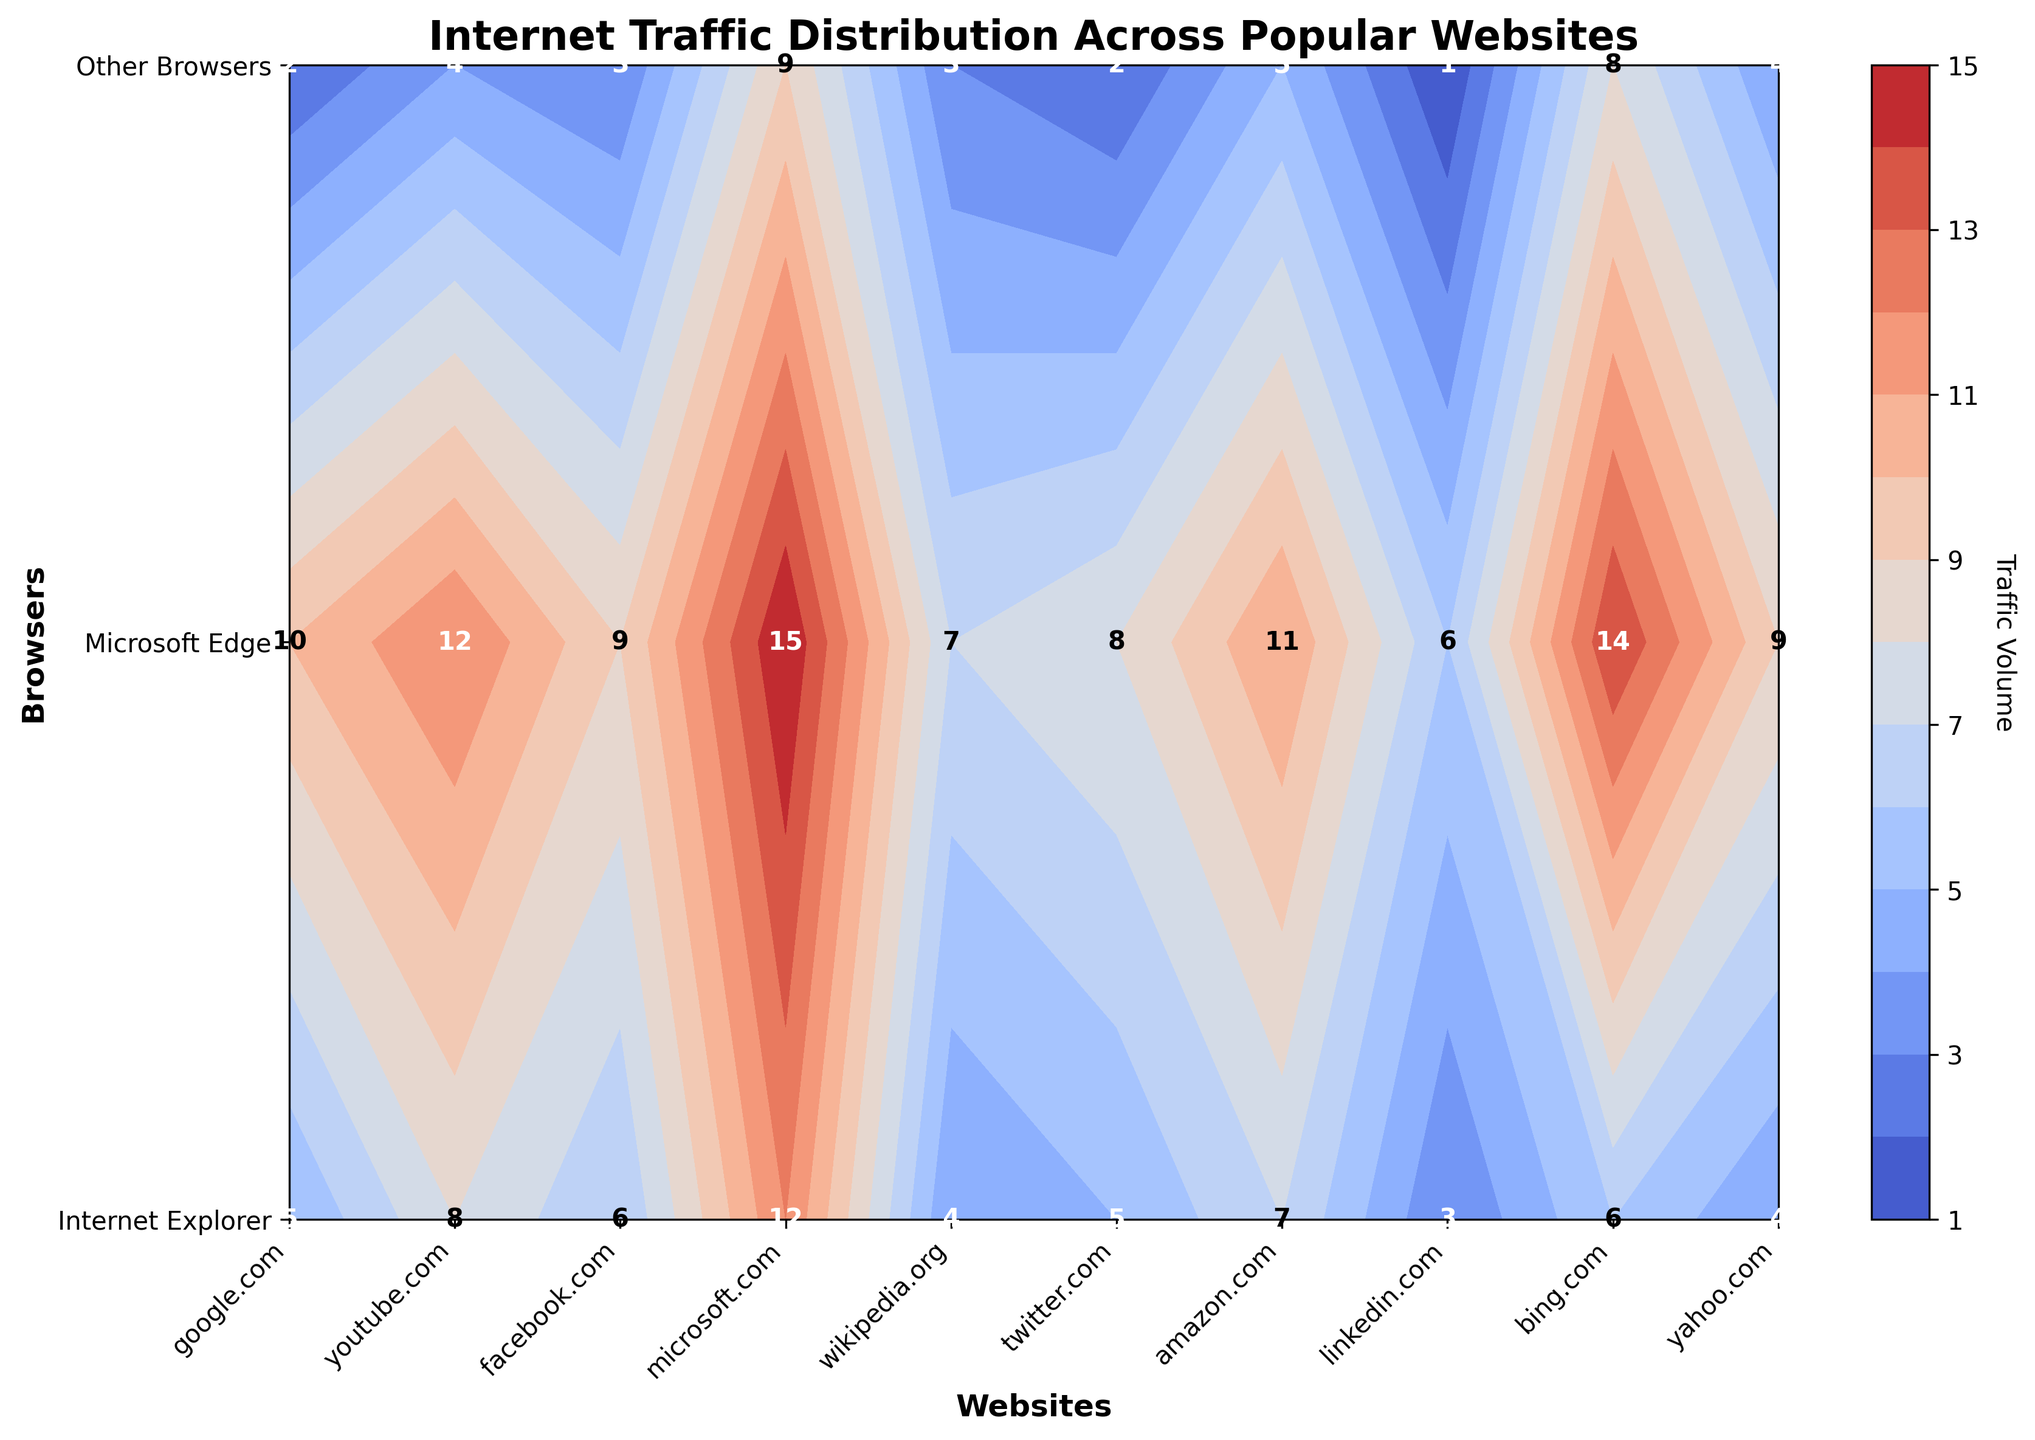What is the title of the plot? The title can be found at the top of the figure, summarizing what the data represents.
Answer: Internet Traffic Distribution Across Popular Websites How many browsers are displayed on the y-axis? The y-axis shows the count of different categories, in this case, the number of distinct browsers. By counting the labels on the y-axis, we find that there are three browsers listed.
Answer: 3 Which website has the highest traffic volume from Microsoft Edge? To determine this, look at the labels in the contour plot for the highest number in the row corresponding to Microsoft Edge. "microsoft.com" has the highest traffic volume with a value of 15.
Answer: microsoft.com Which browser shows the least traffic for linkedin.com? Check the traffic volume values labeled for linkedin.com on the contour plot. The browser with the lowest number is 'Other Browsers' with a value of 1.
Answer: Other Browsers Calculate the total traffic for google.com across all browsers. Sum up the traffic values for google.com across Internet Explorer (5), Microsoft Edge (10), and Other Browsers (2). The total is \(5 + 10 + 2\).
Answer: 17 Which website has the smallest difference in traffic volumes between Internet Explorer and Other Browsers? Calculate the differences between the traffic volumes for Internet Explorer and Other Browsers for each website. The website with the smallest difference will have the lowest absolute difference. For example: google.com (5-2=3), youtube.com (8-4=4), etc. "linkedin.com" has the smallest difference (3-1=2).
Answer: linkedin.com Which websites have an equal traffic volume for Internet Explorer and Other Browsers? Identify websites where the value for Internet Explorer matches the value for Other Browsers. By checking each pair, "wikipedia.org" and "twitter.com" both show equal traffic volumes of 4 and 2 respectively.
Answer: wikipedia.org, twitter.com How does the traffic volume for twitter.com using Microsoft Edge compare to that of twitter.com using Internet Explorer? Compare the labeled traffic values for twitter.com across Microsoft Edge (8) and Internet Explorer (5). Microsoft Edge has a higher traffic volume.
Answer: Microsoft Edge has higher volume What are the colors used in the contour to display varying traffic volumes? The colors in the contour indicate different traffic volumes with a gradient moving from cooler to warmer colors. The specific color map used is 'coolwarm'.
Answer: cool to warm colors What is the average traffic volume for bing.com across all browsers? Calculate the average by summing the traffic volumes for bing.com across Internet Explorer, Microsoft Edge, and Other Browsers, then divide by the number of browsers. \(\frac{6 + 14 + 8}{3} = \frac{28}{3} \approx 9.33\).
Answer: 9.33 